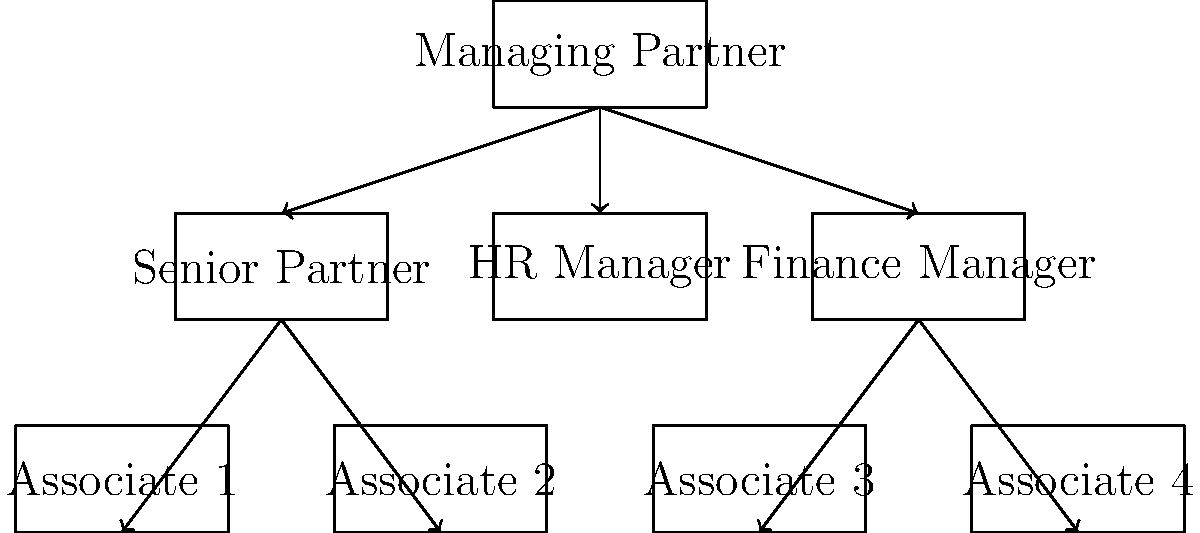Based on the organizational chart of a law firm shown above, which position is responsible for overseeing the largest number of direct reports and plays a crucial role in fostering teamwork and collaboration among different departments? To answer this question, let's analyze the organizational chart step-by-step:

1. The chart shows a hierarchical structure of a law firm.
2. At the top is the Managing Partner, overseeing the entire firm.
3. Directly below the Managing Partner are three positions:
   a. Senior Partner
   b. HR Manager
   c. Finance Manager
4. The Senior Partner oversees two Associates (1 and 2).
5. The Finance Manager oversees two Associates (3 and 4).
6. The HR Manager doesn't have any direct reports shown in this chart.

7. Comparing the number of direct reports:
   - Managing Partner: 3 direct reports
   - Senior Partner: 2 direct reports
   - Finance Manager: 2 direct reports
   - HR Manager: 0 direct reports (based on this chart)

8. The Managing Partner has the most direct reports (3) and is at the top of the hierarchy.
9. This position is crucial for fostering teamwork and collaboration as it oversees all departments (legal, HR, and finance) and can implement firm-wide policies and practices.

Therefore, the Managing Partner is responsible for overseeing the largest number of direct reports and plays a crucial role in fostering teamwork and collaboration among different departments.
Answer: Managing Partner 